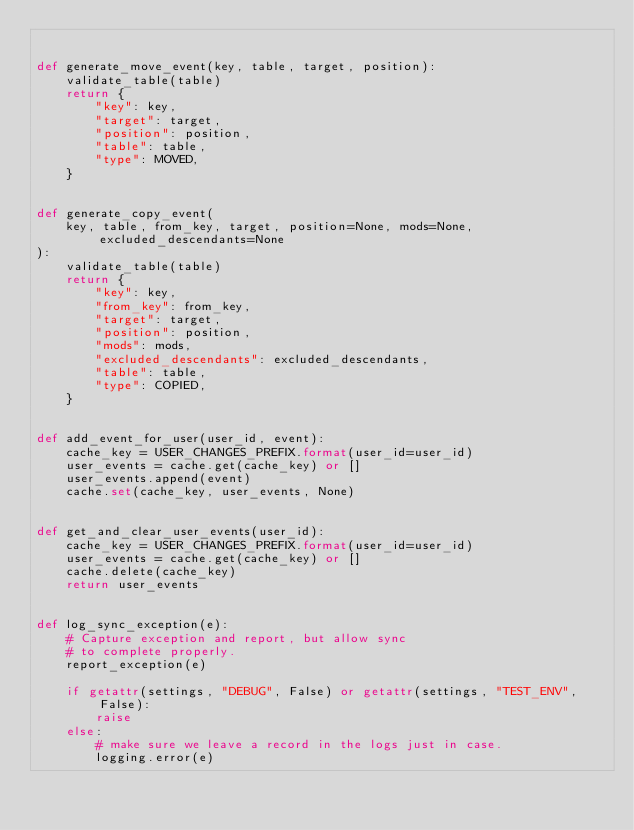<code> <loc_0><loc_0><loc_500><loc_500><_Python_>

def generate_move_event(key, table, target, position):
    validate_table(table)
    return {
        "key": key,
        "target": target,
        "position": position,
        "table": table,
        "type": MOVED,
    }


def generate_copy_event(
    key, table, from_key, target, position=None, mods=None, excluded_descendants=None
):
    validate_table(table)
    return {
        "key": key,
        "from_key": from_key,
        "target": target,
        "position": position,
        "mods": mods,
        "excluded_descendants": excluded_descendants,
        "table": table,
        "type": COPIED,
    }


def add_event_for_user(user_id, event):
    cache_key = USER_CHANGES_PREFIX.format(user_id=user_id)
    user_events = cache.get(cache_key) or []
    user_events.append(event)
    cache.set(cache_key, user_events, None)


def get_and_clear_user_events(user_id):
    cache_key = USER_CHANGES_PREFIX.format(user_id=user_id)
    user_events = cache.get(cache_key) or []
    cache.delete(cache_key)
    return user_events


def log_sync_exception(e):
    # Capture exception and report, but allow sync
    # to complete properly.
    report_exception(e)

    if getattr(settings, "DEBUG", False) or getattr(settings, "TEST_ENV", False):
        raise
    else:
        # make sure we leave a record in the logs just in case.
        logging.error(e)
</code> 